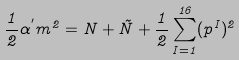<formula> <loc_0><loc_0><loc_500><loc_500>\frac { 1 } { 2 } \alpha ^ { ^ { \prime } } m ^ { 2 } = N + \tilde { N } + \frac { 1 } { 2 } \sum _ { I = 1 } ^ { 1 6 } ( p ^ { I } ) ^ { 2 }</formula> 